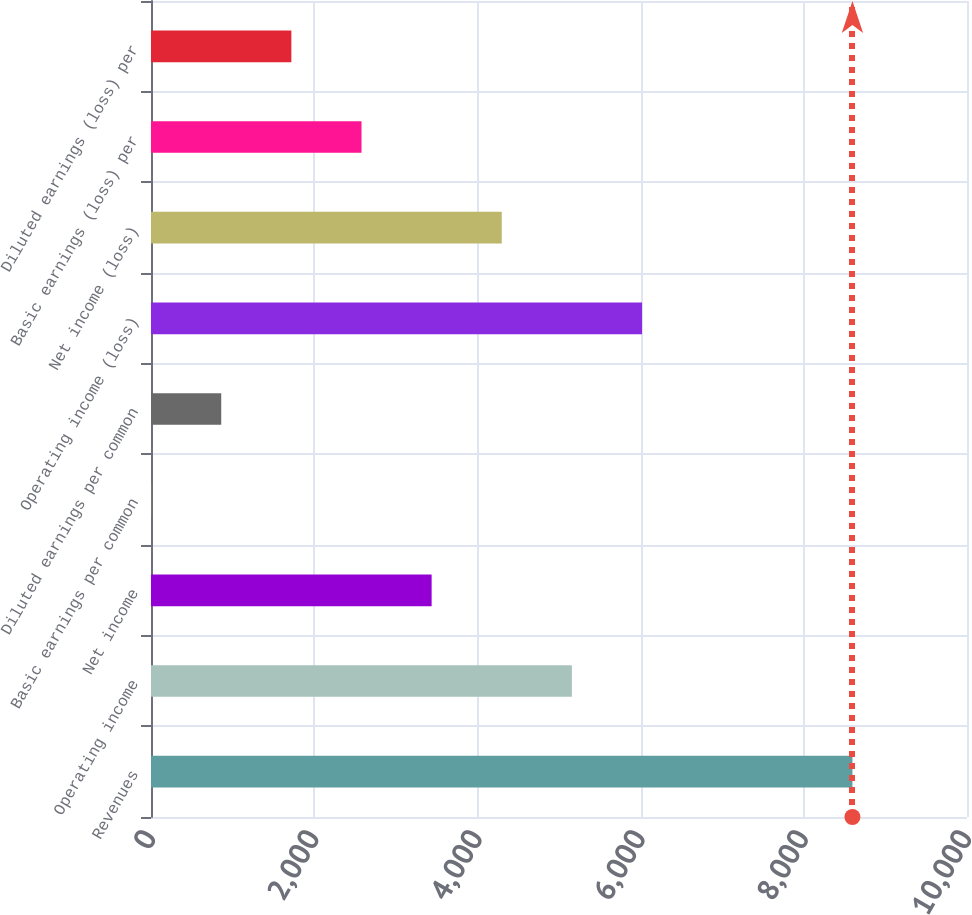<chart> <loc_0><loc_0><loc_500><loc_500><bar_chart><fcel>Revenues<fcel>Operating income<fcel>Net income<fcel>Basic earnings per common<fcel>Diluted earnings per common<fcel>Operating income (loss)<fcel>Net income (loss)<fcel>Basic earnings (loss) per<fcel>Diluted earnings (loss) per<nl><fcel>8596<fcel>5158.04<fcel>3439.06<fcel>1.1<fcel>860.59<fcel>6017.53<fcel>4298.55<fcel>2579.57<fcel>1720.08<nl></chart> 